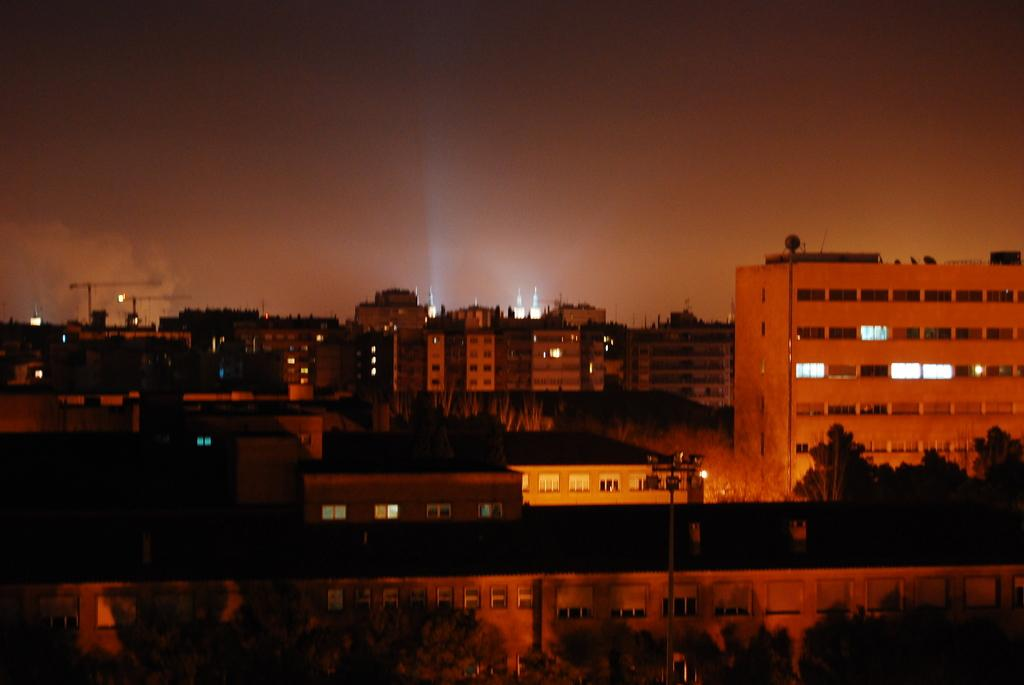What type of structures can be seen in the image? There are buildings in the image. What else is present in the image besides buildings? There are poles and trees in the image. What part of the natural environment is visible in the image? The sky is visible in the image. What type of linen is draped over the hill in the image? There is no hill or linen present in the image. What agreement was reached between the trees and the buildings in the image? There is no agreement between the trees and the buildings in the image, as they are inanimate objects. 